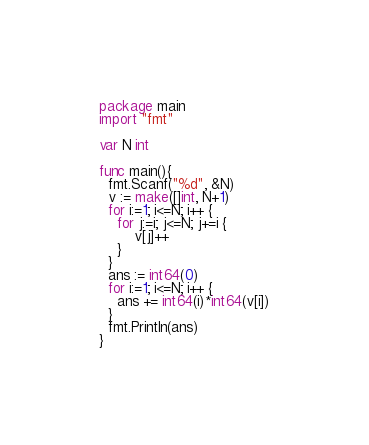Convert code to text. <code><loc_0><loc_0><loc_500><loc_500><_Go_>package main
import "fmt"

var N int

func main(){
  fmt.Scanf("%d", &N)
  v := make([]int, N+1)
  for i:=1; i<=N; i++ {
    for j:=i; j<=N; j+=i {
    	v[j]++
    } 
  }
  ans := int64(0)
  for i:=1; i<=N; i++ {
    ans += int64(i)*int64(v[i])
  }
  fmt.Println(ans)
}</code> 